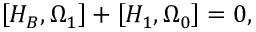Convert formula to latex. <formula><loc_0><loc_0><loc_500><loc_500>\left [ H _ { B } , \Omega _ { 1 } \right ] + \left [ H _ { 1 } , \Omega _ { 0 } \right ] = 0 ,</formula> 